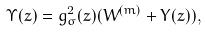<formula> <loc_0><loc_0><loc_500><loc_500>\Upsilon ( z ) = g _ { \sigma } ^ { 2 } ( z ) ( W ^ { ( m ) } + Y ( z ) ) ,</formula> 